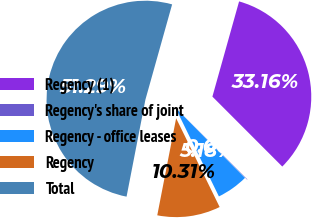Convert chart to OTSL. <chart><loc_0><loc_0><loc_500><loc_500><pie_chart><fcel>Regency (1)<fcel>Regency's share of joint<fcel>Regency - office leases<fcel>Regency<fcel>Total<nl><fcel>33.16%<fcel>0.06%<fcel>5.18%<fcel>10.31%<fcel>51.3%<nl></chart> 